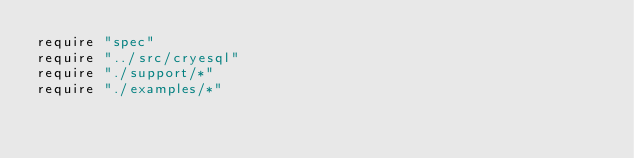Convert code to text. <code><loc_0><loc_0><loc_500><loc_500><_Crystal_>require "spec"
require "../src/cryesql"
require "./support/*"
require "./examples/*"
</code> 